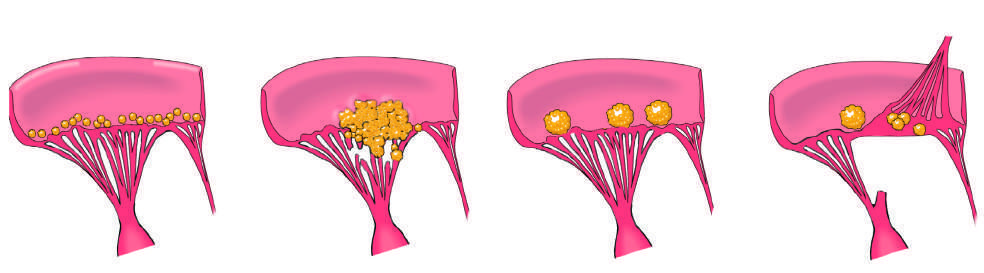does the inflammation resolve?
Answer the question using a single word or phrase. Yes 